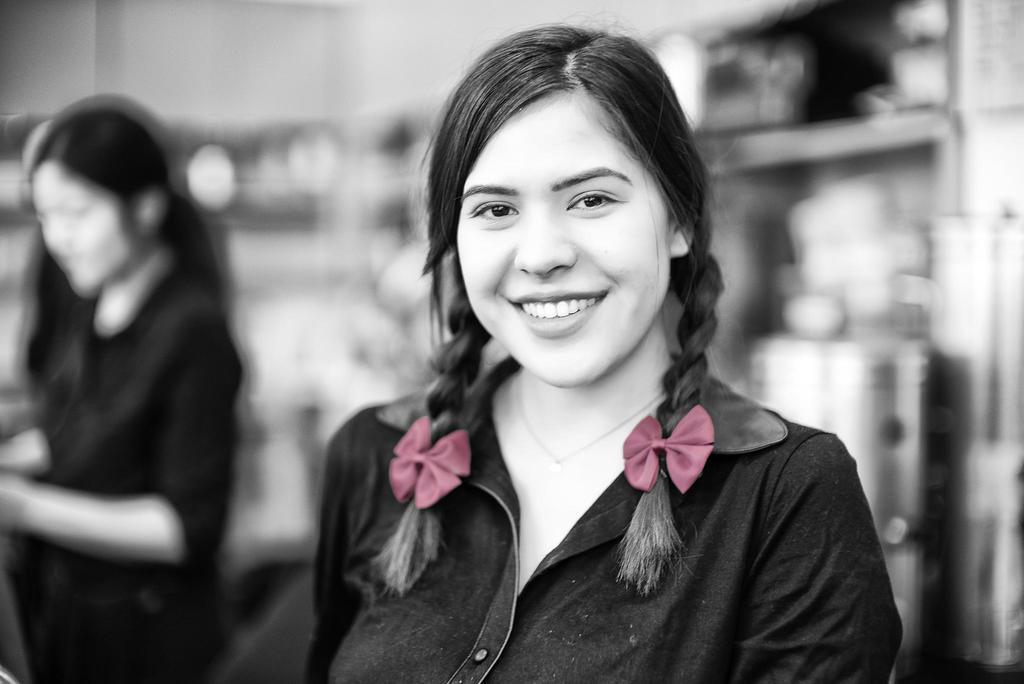Could you give a brief overview of what you see in this image? In this image in the foreground there is a woman, she is smiling , background is blurry, on the left side there is another woman visible. 